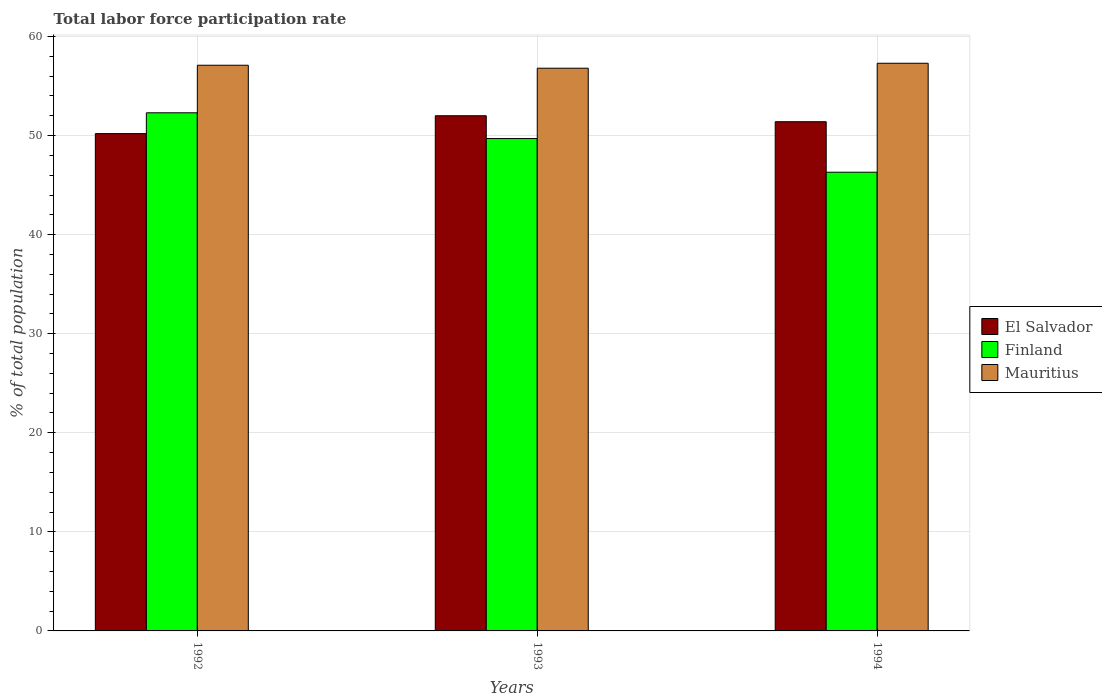How many different coloured bars are there?
Provide a short and direct response. 3. How many groups of bars are there?
Keep it short and to the point. 3. Are the number of bars per tick equal to the number of legend labels?
Offer a terse response. Yes. Are the number of bars on each tick of the X-axis equal?
Ensure brevity in your answer.  Yes. In how many cases, is the number of bars for a given year not equal to the number of legend labels?
Provide a succinct answer. 0. What is the total labor force participation rate in El Salvador in 1992?
Your answer should be very brief. 50.2. Across all years, what is the maximum total labor force participation rate in Finland?
Keep it short and to the point. 52.3. Across all years, what is the minimum total labor force participation rate in Finland?
Offer a terse response. 46.3. In which year was the total labor force participation rate in Mauritius maximum?
Offer a very short reply. 1994. In which year was the total labor force participation rate in El Salvador minimum?
Your response must be concise. 1992. What is the total total labor force participation rate in El Salvador in the graph?
Offer a terse response. 153.6. What is the difference between the total labor force participation rate in Mauritius in 1992 and that in 1994?
Provide a short and direct response. -0.2. What is the difference between the total labor force participation rate in Finland in 1992 and the total labor force participation rate in Mauritius in 1994?
Provide a short and direct response. -5. What is the average total labor force participation rate in El Salvador per year?
Keep it short and to the point. 51.2. In the year 1994, what is the difference between the total labor force participation rate in Mauritius and total labor force participation rate in El Salvador?
Give a very brief answer. 5.9. What is the ratio of the total labor force participation rate in Finland in 1992 to that in 1993?
Make the answer very short. 1.05. Is the total labor force participation rate in El Salvador in 1992 less than that in 1993?
Your response must be concise. Yes. What is the difference between the highest and the second highest total labor force participation rate in El Salvador?
Your response must be concise. 0.6. What is the difference between the highest and the lowest total labor force participation rate in El Salvador?
Keep it short and to the point. 1.8. In how many years, is the total labor force participation rate in El Salvador greater than the average total labor force participation rate in El Salvador taken over all years?
Provide a short and direct response. 2. Is the sum of the total labor force participation rate in El Salvador in 1992 and 1993 greater than the maximum total labor force participation rate in Mauritius across all years?
Offer a terse response. Yes. What does the 2nd bar from the right in 1994 represents?
Make the answer very short. Finland. How many bars are there?
Give a very brief answer. 9. What is the difference between two consecutive major ticks on the Y-axis?
Provide a short and direct response. 10. Does the graph contain any zero values?
Make the answer very short. No. Does the graph contain grids?
Your answer should be very brief. Yes. Where does the legend appear in the graph?
Offer a very short reply. Center right. What is the title of the graph?
Your response must be concise. Total labor force participation rate. What is the label or title of the Y-axis?
Your answer should be very brief. % of total population. What is the % of total population of El Salvador in 1992?
Provide a succinct answer. 50.2. What is the % of total population in Finland in 1992?
Make the answer very short. 52.3. What is the % of total population in Mauritius in 1992?
Your answer should be very brief. 57.1. What is the % of total population of Finland in 1993?
Offer a very short reply. 49.7. What is the % of total population in Mauritius in 1993?
Your answer should be compact. 56.8. What is the % of total population of El Salvador in 1994?
Your answer should be very brief. 51.4. What is the % of total population of Finland in 1994?
Give a very brief answer. 46.3. What is the % of total population in Mauritius in 1994?
Make the answer very short. 57.3. Across all years, what is the maximum % of total population in El Salvador?
Give a very brief answer. 52. Across all years, what is the maximum % of total population in Finland?
Provide a short and direct response. 52.3. Across all years, what is the maximum % of total population in Mauritius?
Your response must be concise. 57.3. Across all years, what is the minimum % of total population of El Salvador?
Keep it short and to the point. 50.2. Across all years, what is the minimum % of total population in Finland?
Your answer should be very brief. 46.3. Across all years, what is the minimum % of total population of Mauritius?
Keep it short and to the point. 56.8. What is the total % of total population in El Salvador in the graph?
Your answer should be very brief. 153.6. What is the total % of total population in Finland in the graph?
Ensure brevity in your answer.  148.3. What is the total % of total population of Mauritius in the graph?
Offer a terse response. 171.2. What is the difference between the % of total population of Finland in 1992 and that in 1994?
Your response must be concise. 6. What is the difference between the % of total population in El Salvador in 1992 and the % of total population in Mauritius in 1993?
Offer a terse response. -6.6. What is the difference between the % of total population of El Salvador in 1992 and the % of total population of Mauritius in 1994?
Offer a very short reply. -7.1. What is the difference between the % of total population in Finland in 1992 and the % of total population in Mauritius in 1994?
Your answer should be compact. -5. What is the difference between the % of total population of El Salvador in 1993 and the % of total population of Mauritius in 1994?
Make the answer very short. -5.3. What is the difference between the % of total population of Finland in 1993 and the % of total population of Mauritius in 1994?
Provide a short and direct response. -7.6. What is the average % of total population of El Salvador per year?
Give a very brief answer. 51.2. What is the average % of total population in Finland per year?
Keep it short and to the point. 49.43. What is the average % of total population in Mauritius per year?
Ensure brevity in your answer.  57.07. In the year 1992, what is the difference between the % of total population of El Salvador and % of total population of Mauritius?
Give a very brief answer. -6.9. In the year 1992, what is the difference between the % of total population of Finland and % of total population of Mauritius?
Offer a very short reply. -4.8. In the year 1993, what is the difference between the % of total population in El Salvador and % of total population in Finland?
Ensure brevity in your answer.  2.3. In the year 1993, what is the difference between the % of total population of El Salvador and % of total population of Mauritius?
Your answer should be compact. -4.8. In the year 1993, what is the difference between the % of total population of Finland and % of total population of Mauritius?
Make the answer very short. -7.1. In the year 1994, what is the difference between the % of total population in El Salvador and % of total population in Finland?
Give a very brief answer. 5.1. What is the ratio of the % of total population in El Salvador in 1992 to that in 1993?
Provide a short and direct response. 0.97. What is the ratio of the % of total population in Finland in 1992 to that in 1993?
Provide a succinct answer. 1.05. What is the ratio of the % of total population in Mauritius in 1992 to that in 1993?
Ensure brevity in your answer.  1.01. What is the ratio of the % of total population in El Salvador in 1992 to that in 1994?
Your response must be concise. 0.98. What is the ratio of the % of total population in Finland in 1992 to that in 1994?
Ensure brevity in your answer.  1.13. What is the ratio of the % of total population of El Salvador in 1993 to that in 1994?
Provide a succinct answer. 1.01. What is the ratio of the % of total population in Finland in 1993 to that in 1994?
Your response must be concise. 1.07. What is the ratio of the % of total population of Mauritius in 1993 to that in 1994?
Your answer should be compact. 0.99. What is the difference between the highest and the lowest % of total population of Mauritius?
Your answer should be very brief. 0.5. 